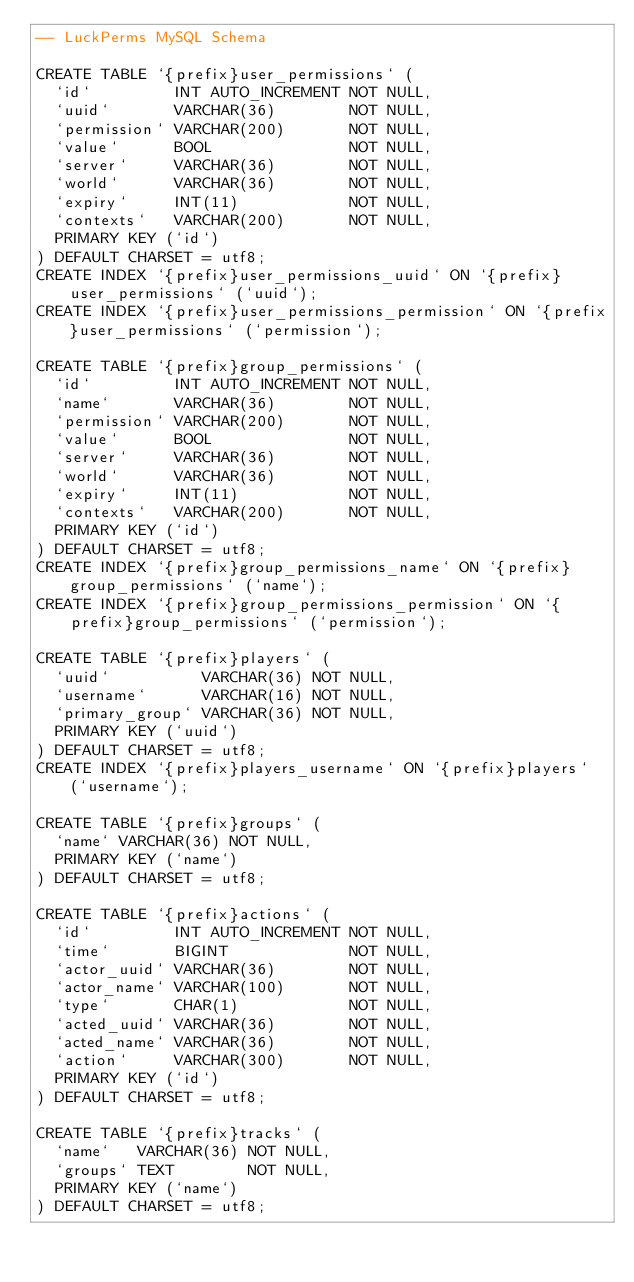Convert code to text. <code><loc_0><loc_0><loc_500><loc_500><_SQL_>-- LuckPerms MySQL Schema

CREATE TABLE `{prefix}user_permissions` (
  `id`         INT AUTO_INCREMENT NOT NULL,
  `uuid`       VARCHAR(36)        NOT NULL,
  `permission` VARCHAR(200)       NOT NULL,
  `value`      BOOL               NOT NULL,
  `server`     VARCHAR(36)        NOT NULL,
  `world`      VARCHAR(36)        NOT NULL,
  `expiry`     INT(11)            NOT NULL,
  `contexts`   VARCHAR(200)       NOT NULL,
  PRIMARY KEY (`id`)
) DEFAULT CHARSET = utf8;
CREATE INDEX `{prefix}user_permissions_uuid` ON `{prefix}user_permissions` (`uuid`);
CREATE INDEX `{prefix}user_permissions_permission` ON `{prefix}user_permissions` (`permission`);

CREATE TABLE `{prefix}group_permissions` (
  `id`         INT AUTO_INCREMENT NOT NULL,
  `name`       VARCHAR(36)        NOT NULL,
  `permission` VARCHAR(200)       NOT NULL,
  `value`      BOOL               NOT NULL,
  `server`     VARCHAR(36)        NOT NULL,
  `world`      VARCHAR(36)        NOT NULL,
  `expiry`     INT(11)            NOT NULL,
  `contexts`   VARCHAR(200)       NOT NULL,
  PRIMARY KEY (`id`)
) DEFAULT CHARSET = utf8;
CREATE INDEX `{prefix}group_permissions_name` ON `{prefix}group_permissions` (`name`);
CREATE INDEX `{prefix}group_permissions_permission` ON `{prefix}group_permissions` (`permission`);

CREATE TABLE `{prefix}players` (
  `uuid`          VARCHAR(36) NOT NULL,
  `username`      VARCHAR(16) NOT NULL,
  `primary_group` VARCHAR(36) NOT NULL,
  PRIMARY KEY (`uuid`)
) DEFAULT CHARSET = utf8;
CREATE INDEX `{prefix}players_username` ON `{prefix}players` (`username`);

CREATE TABLE `{prefix}groups` (
  `name` VARCHAR(36) NOT NULL,
  PRIMARY KEY (`name`)
) DEFAULT CHARSET = utf8;

CREATE TABLE `{prefix}actions` (
  `id`         INT AUTO_INCREMENT NOT NULL,
  `time`       BIGINT             NOT NULL,
  `actor_uuid` VARCHAR(36)        NOT NULL,
  `actor_name` VARCHAR(100)       NOT NULL,
  `type`       CHAR(1)            NOT NULL,
  `acted_uuid` VARCHAR(36)        NOT NULL,
  `acted_name` VARCHAR(36)        NOT NULL,
  `action`     VARCHAR(300)       NOT NULL,
  PRIMARY KEY (`id`)
) DEFAULT CHARSET = utf8;

CREATE TABLE `{prefix}tracks` (
  `name`   VARCHAR(36) NOT NULL,
  `groups` TEXT        NOT NULL,
  PRIMARY KEY (`name`)
) DEFAULT CHARSET = utf8;</code> 